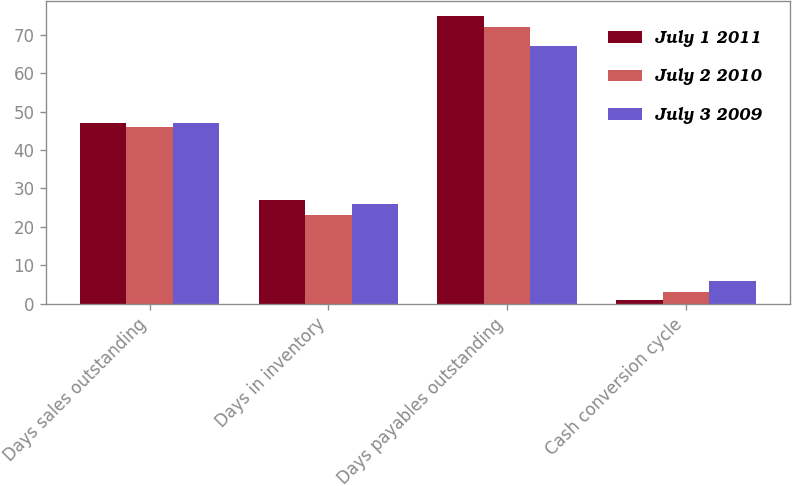Convert chart to OTSL. <chart><loc_0><loc_0><loc_500><loc_500><stacked_bar_chart><ecel><fcel>Days sales outstanding<fcel>Days in inventory<fcel>Days payables outstanding<fcel>Cash conversion cycle<nl><fcel>July 1 2011<fcel>47<fcel>27<fcel>75<fcel>1<nl><fcel>July 2 2010<fcel>46<fcel>23<fcel>72<fcel>3<nl><fcel>July 3 2009<fcel>47<fcel>26<fcel>67<fcel>6<nl></chart> 